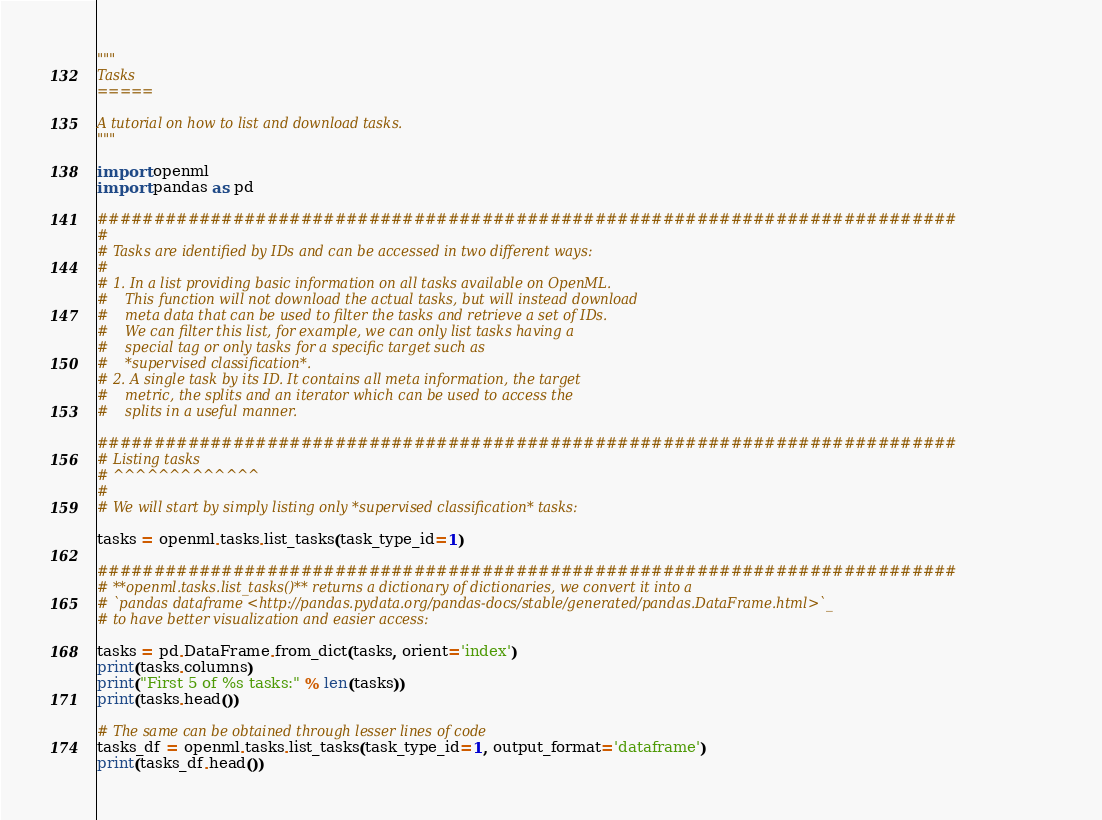<code> <loc_0><loc_0><loc_500><loc_500><_Python_>"""
Tasks
=====

A tutorial on how to list and download tasks.
"""

import openml
import pandas as pd

############################################################################
#
# Tasks are identified by IDs and can be accessed in two different ways:
#
# 1. In a list providing basic information on all tasks available on OpenML.
#    This function will not download the actual tasks, but will instead download
#    meta data that can be used to filter the tasks and retrieve a set of IDs.
#    We can filter this list, for example, we can only list tasks having a
#    special tag or only tasks for a specific target such as
#    *supervised classification*.
# 2. A single task by its ID. It contains all meta information, the target
#    metric, the splits and an iterator which can be used to access the
#    splits in a useful manner.

############################################################################
# Listing tasks
# ^^^^^^^^^^^^^
#
# We will start by simply listing only *supervised classification* tasks:

tasks = openml.tasks.list_tasks(task_type_id=1)

############################################################################
# **openml.tasks.list_tasks()** returns a dictionary of dictionaries, we convert it into a
# `pandas dataframe <http://pandas.pydata.org/pandas-docs/stable/generated/pandas.DataFrame.html>`_
# to have better visualization and easier access:

tasks = pd.DataFrame.from_dict(tasks, orient='index')
print(tasks.columns)
print("First 5 of %s tasks:" % len(tasks))
print(tasks.head())

# The same can be obtained through lesser lines of code
tasks_df = openml.tasks.list_tasks(task_type_id=1, output_format='dataframe')
print(tasks_df.head())
</code> 